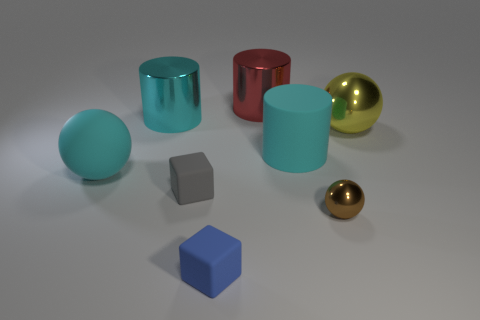Is the number of small brown metallic objects that are in front of the big red shiny object the same as the number of cyan matte spheres?
Your answer should be very brief. Yes. What number of objects are either large matte cubes or cyan cylinders that are in front of the big yellow metal ball?
Make the answer very short. 1. Is the matte cylinder the same color as the big matte sphere?
Provide a short and direct response. Yes. Is there a blue block that has the same material as the yellow sphere?
Provide a short and direct response. No. What is the color of the other matte object that is the same shape as the gray matte thing?
Offer a very short reply. Blue. Are the gray block and the thing on the right side of the brown sphere made of the same material?
Give a very brief answer. No. The large cyan matte object left of the cylinder that is left of the gray rubber thing is what shape?
Make the answer very short. Sphere. There is a shiny ball to the right of the brown sphere; does it have the same size as the large red cylinder?
Offer a very short reply. Yes. How many other objects are there of the same shape as the large red shiny object?
Ensure brevity in your answer.  2. There is a matte block that is in front of the brown object; does it have the same color as the large metal sphere?
Provide a succinct answer. No. 